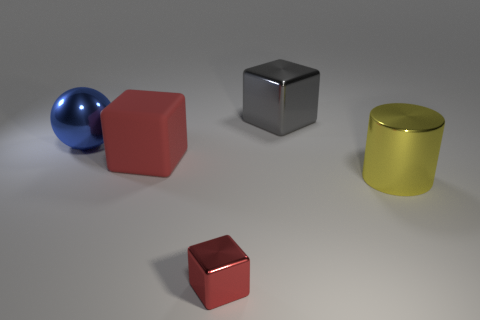Subtract all big red cubes. How many cubes are left? 2 Subtract 2 cubes. How many cubes are left? 1 Subtract all gray blocks. How many blocks are left? 2 Subtract all yellow spheres. How many red cylinders are left? 0 Subtract all big yellow objects. Subtract all large matte objects. How many objects are left? 3 Add 5 big balls. How many big balls are left? 6 Add 2 tiny matte cylinders. How many tiny matte cylinders exist? 2 Add 4 matte blocks. How many objects exist? 9 Subtract 0 gray cylinders. How many objects are left? 5 Subtract all cylinders. How many objects are left? 4 